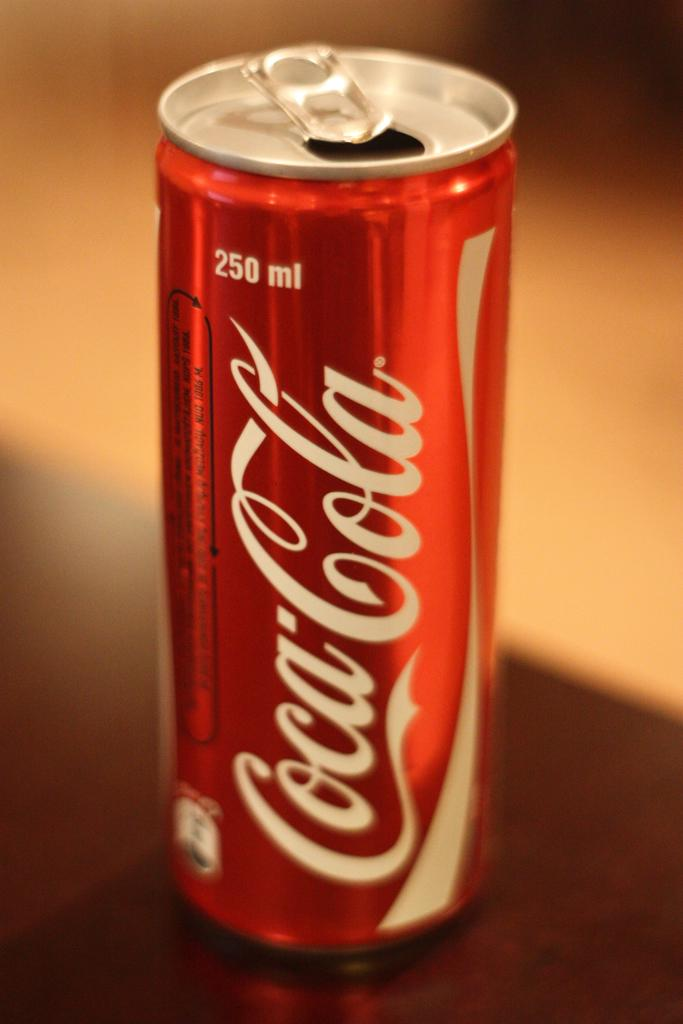<image>
Relay a brief, clear account of the picture shown. An open can of Coca-Colon sits on a wooden surface. 